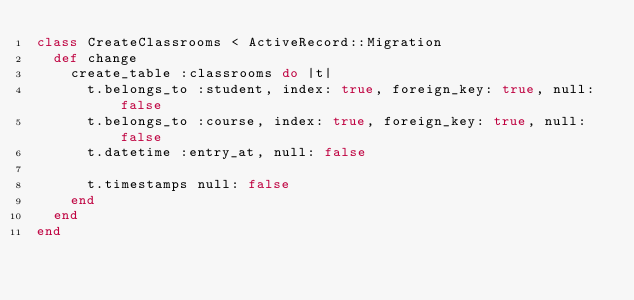Convert code to text. <code><loc_0><loc_0><loc_500><loc_500><_Ruby_>class CreateClassrooms < ActiveRecord::Migration
  def change
    create_table :classrooms do |t|
      t.belongs_to :student, index: true, foreign_key: true, null: false
      t.belongs_to :course, index: true, foreign_key: true, null: false
      t.datetime :entry_at, null: false

      t.timestamps null: false
    end
  end
end</code> 